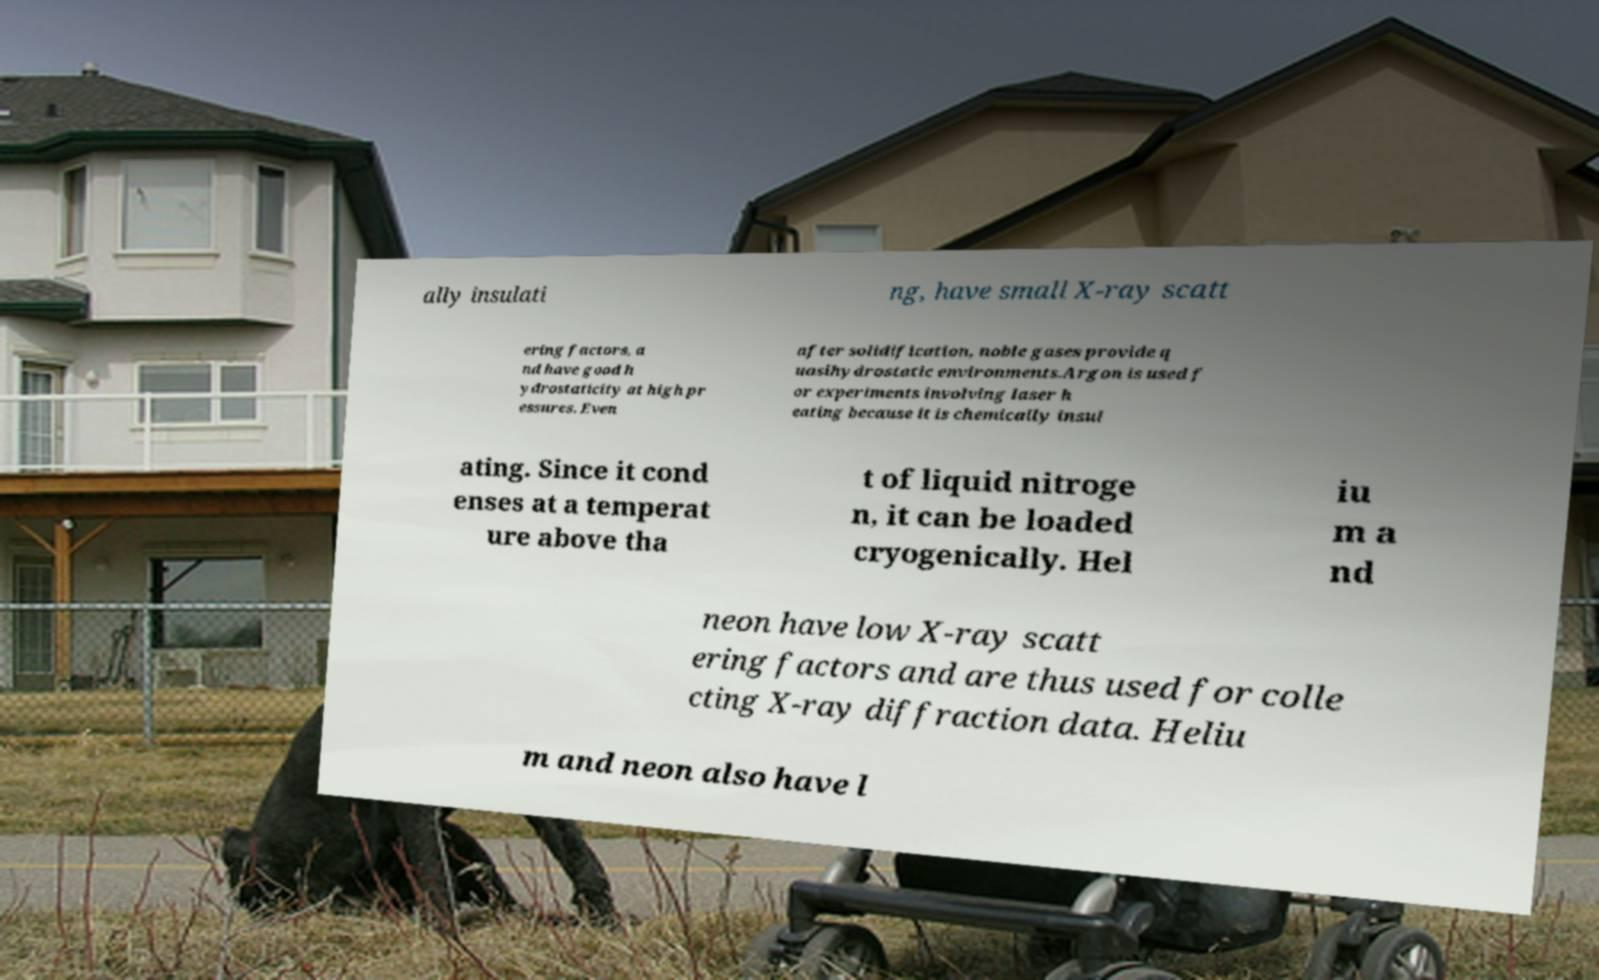I need the written content from this picture converted into text. Can you do that? ally insulati ng, have small X-ray scatt ering factors, a nd have good h ydrostaticity at high pr essures. Even after solidification, noble gases provide q uasihydrostatic environments.Argon is used f or experiments involving laser h eating because it is chemically insul ating. Since it cond enses at a temperat ure above tha t of liquid nitroge n, it can be loaded cryogenically. Hel iu m a nd neon have low X-ray scatt ering factors and are thus used for colle cting X-ray diffraction data. Heliu m and neon also have l 